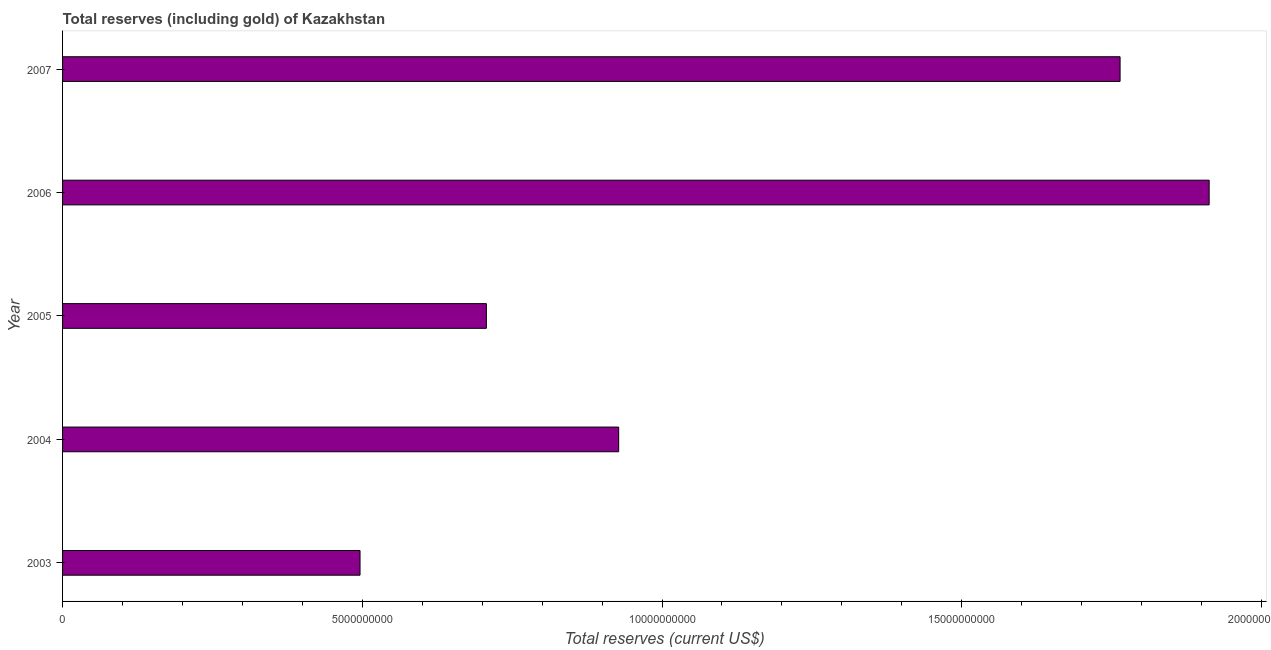Does the graph contain any zero values?
Your answer should be very brief. No. Does the graph contain grids?
Ensure brevity in your answer.  No. What is the title of the graph?
Keep it short and to the point. Total reserves (including gold) of Kazakhstan. What is the label or title of the X-axis?
Keep it short and to the point. Total reserves (current US$). What is the total reserves (including gold) in 2007?
Provide a succinct answer. 1.76e+1. Across all years, what is the maximum total reserves (including gold)?
Make the answer very short. 1.91e+1. Across all years, what is the minimum total reserves (including gold)?
Keep it short and to the point. 4.96e+09. In which year was the total reserves (including gold) maximum?
Ensure brevity in your answer.  2006. In which year was the total reserves (including gold) minimum?
Provide a succinct answer. 2003. What is the sum of the total reserves (including gold)?
Your response must be concise. 5.81e+1. What is the difference between the total reserves (including gold) in 2005 and 2007?
Keep it short and to the point. -1.06e+1. What is the average total reserves (including gold) per year?
Offer a very short reply. 1.16e+1. What is the median total reserves (including gold)?
Your answer should be compact. 9.28e+09. In how many years, is the total reserves (including gold) greater than 12000000000 US$?
Provide a succinct answer. 2. Do a majority of the years between 2003 and 2004 (inclusive) have total reserves (including gold) greater than 3000000000 US$?
Provide a short and direct response. Yes. What is the ratio of the total reserves (including gold) in 2004 to that in 2007?
Provide a succinct answer. 0.53. What is the difference between the highest and the second highest total reserves (including gold)?
Keep it short and to the point. 1.49e+09. What is the difference between the highest and the lowest total reserves (including gold)?
Offer a terse response. 1.42e+1. How many years are there in the graph?
Your response must be concise. 5. What is the difference between two consecutive major ticks on the X-axis?
Ensure brevity in your answer.  5.00e+09. Are the values on the major ticks of X-axis written in scientific E-notation?
Offer a terse response. No. What is the Total reserves (current US$) in 2003?
Your answer should be very brief. 4.96e+09. What is the Total reserves (current US$) of 2004?
Make the answer very short. 9.28e+09. What is the Total reserves (current US$) of 2005?
Offer a very short reply. 7.07e+09. What is the Total reserves (current US$) in 2006?
Offer a terse response. 1.91e+1. What is the Total reserves (current US$) in 2007?
Your answer should be compact. 1.76e+1. What is the difference between the Total reserves (current US$) in 2003 and 2004?
Provide a short and direct response. -4.31e+09. What is the difference between the Total reserves (current US$) in 2003 and 2005?
Your answer should be very brief. -2.11e+09. What is the difference between the Total reserves (current US$) in 2003 and 2006?
Provide a short and direct response. -1.42e+1. What is the difference between the Total reserves (current US$) in 2003 and 2007?
Keep it short and to the point. -1.27e+1. What is the difference between the Total reserves (current US$) in 2004 and 2005?
Offer a terse response. 2.21e+09. What is the difference between the Total reserves (current US$) in 2004 and 2006?
Provide a succinct answer. -9.85e+09. What is the difference between the Total reserves (current US$) in 2004 and 2007?
Provide a short and direct response. -8.36e+09. What is the difference between the Total reserves (current US$) in 2005 and 2006?
Offer a very short reply. -1.21e+1. What is the difference between the Total reserves (current US$) in 2005 and 2007?
Give a very brief answer. -1.06e+1. What is the difference between the Total reserves (current US$) in 2006 and 2007?
Keep it short and to the point. 1.49e+09. What is the ratio of the Total reserves (current US$) in 2003 to that in 2004?
Make the answer very short. 0.54. What is the ratio of the Total reserves (current US$) in 2003 to that in 2005?
Ensure brevity in your answer.  0.7. What is the ratio of the Total reserves (current US$) in 2003 to that in 2006?
Offer a very short reply. 0.26. What is the ratio of the Total reserves (current US$) in 2003 to that in 2007?
Keep it short and to the point. 0.28. What is the ratio of the Total reserves (current US$) in 2004 to that in 2005?
Your answer should be compact. 1.31. What is the ratio of the Total reserves (current US$) in 2004 to that in 2006?
Your response must be concise. 0.48. What is the ratio of the Total reserves (current US$) in 2004 to that in 2007?
Keep it short and to the point. 0.53. What is the ratio of the Total reserves (current US$) in 2005 to that in 2006?
Provide a short and direct response. 0.37. What is the ratio of the Total reserves (current US$) in 2005 to that in 2007?
Ensure brevity in your answer.  0.4. What is the ratio of the Total reserves (current US$) in 2006 to that in 2007?
Your response must be concise. 1.08. 